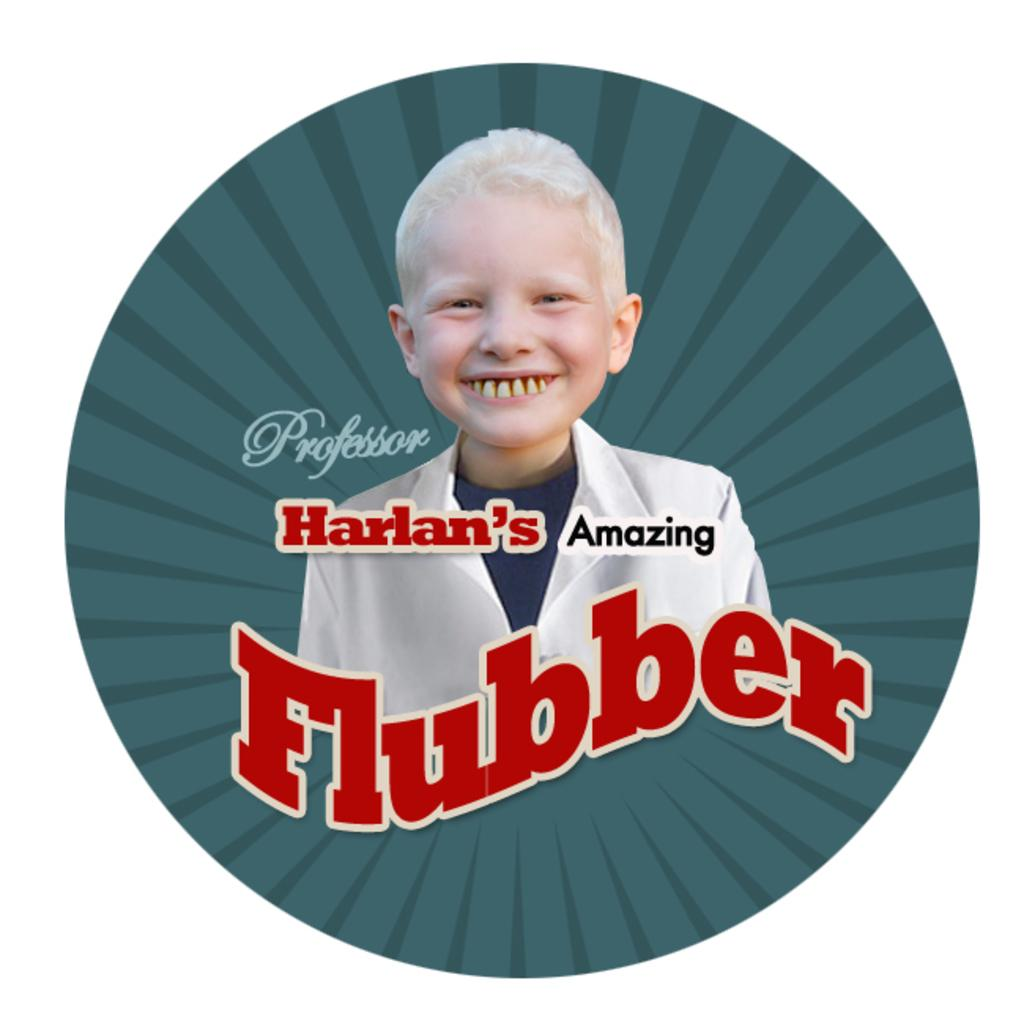<image>
Give a short and clear explanation of the subsequent image. A picture of a smiling child in with the words Professor Harlan's Amazing Flubber on it. 